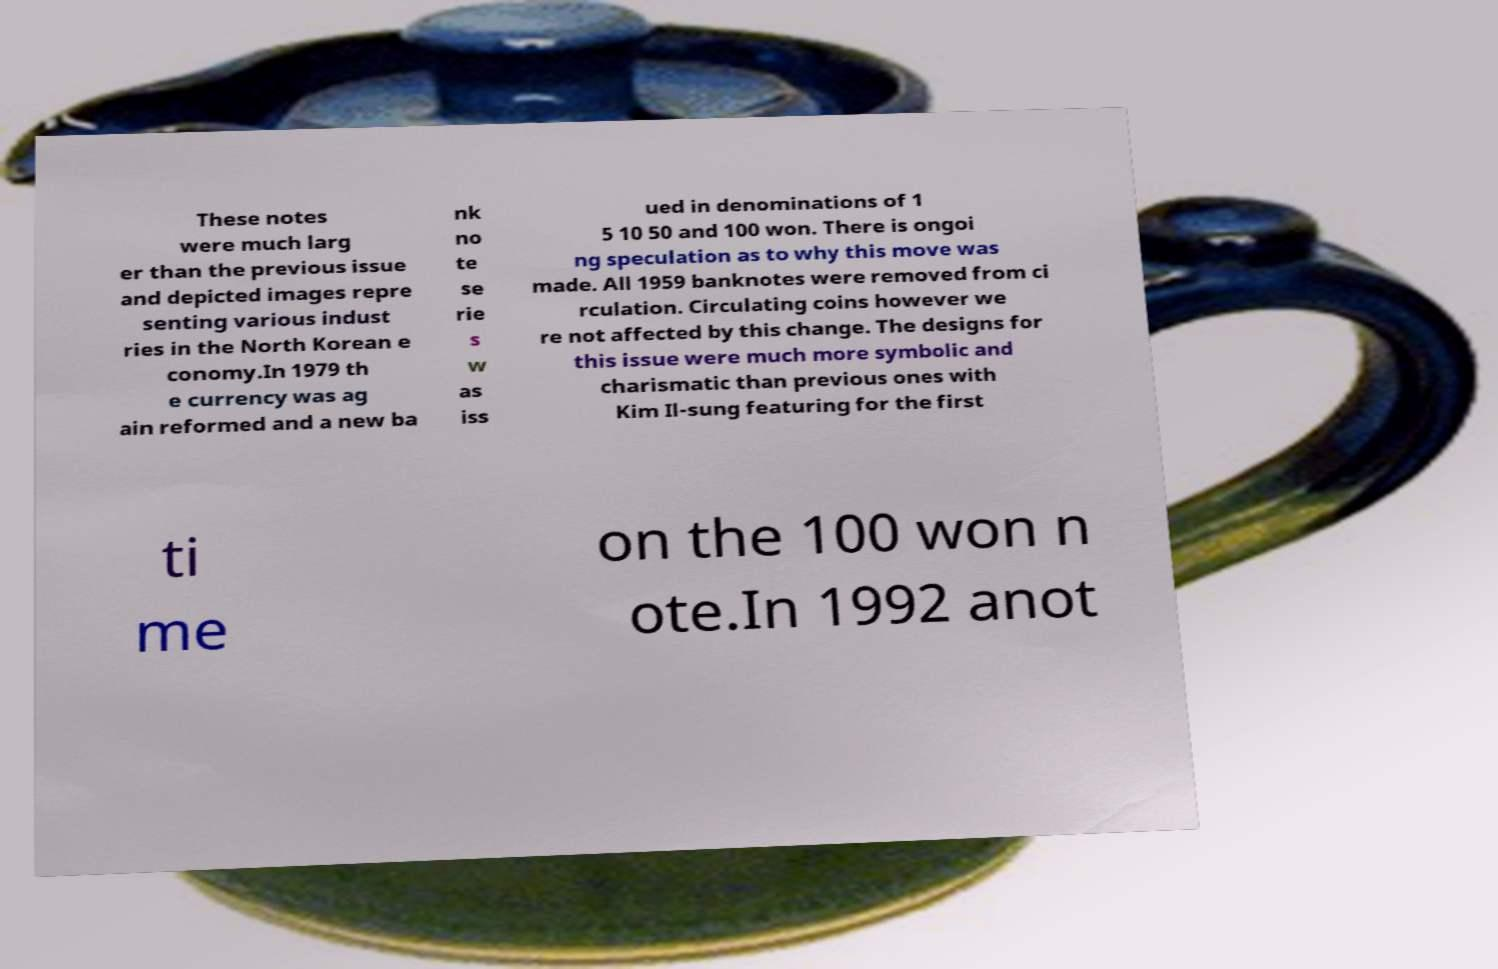What messages or text are displayed in this image? I need them in a readable, typed format. These notes were much larg er than the previous issue and depicted images repre senting various indust ries in the North Korean e conomy.In 1979 th e currency was ag ain reformed and a new ba nk no te se rie s w as iss ued in denominations of 1 5 10 50 and 100 won. There is ongoi ng speculation as to why this move was made. All 1959 banknotes were removed from ci rculation. Circulating coins however we re not affected by this change. The designs for this issue were much more symbolic and charismatic than previous ones with Kim Il-sung featuring for the first ti me on the 100 won n ote.In 1992 anot 